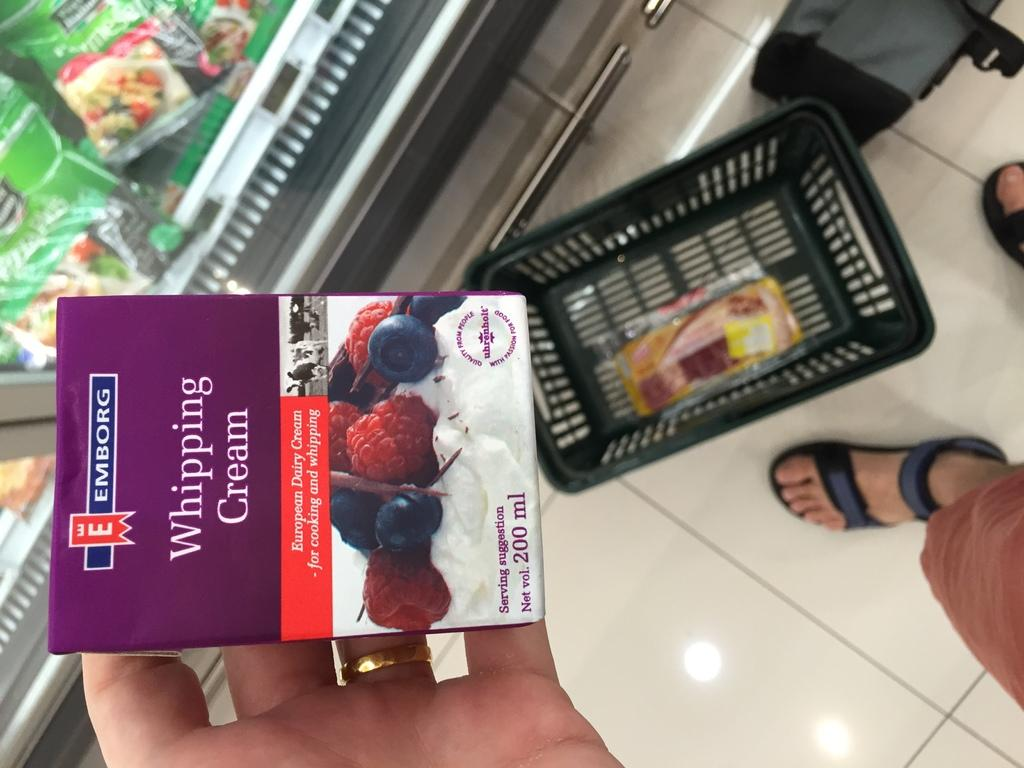<image>
Describe the image concisely. A carton of whipping cream is being held above a basket. 